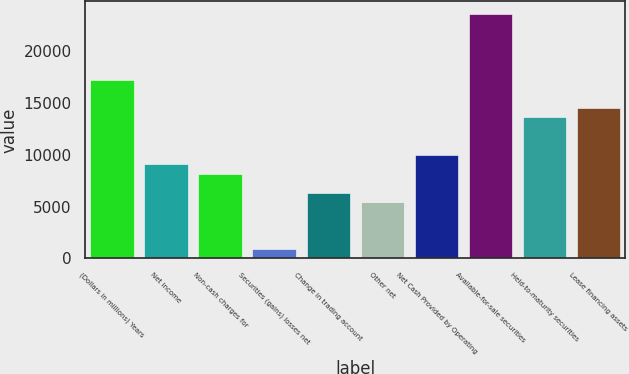Convert chart. <chart><loc_0><loc_0><loc_500><loc_500><bar_chart><fcel>(Dollars in millions) Years<fcel>Net income<fcel>Non-cash charges for<fcel>Securities (gains) losses net<fcel>Change in trading account<fcel>Other net<fcel>Net Cash Provided by Operating<fcel>Available-for-sale securities<fcel>Held-to-maturity securities<fcel>Lease financing assets<nl><fcel>17287.2<fcel>9099<fcel>8189.2<fcel>910.8<fcel>6369.6<fcel>5459.8<fcel>10008.8<fcel>23655.8<fcel>13648<fcel>14557.8<nl></chart> 